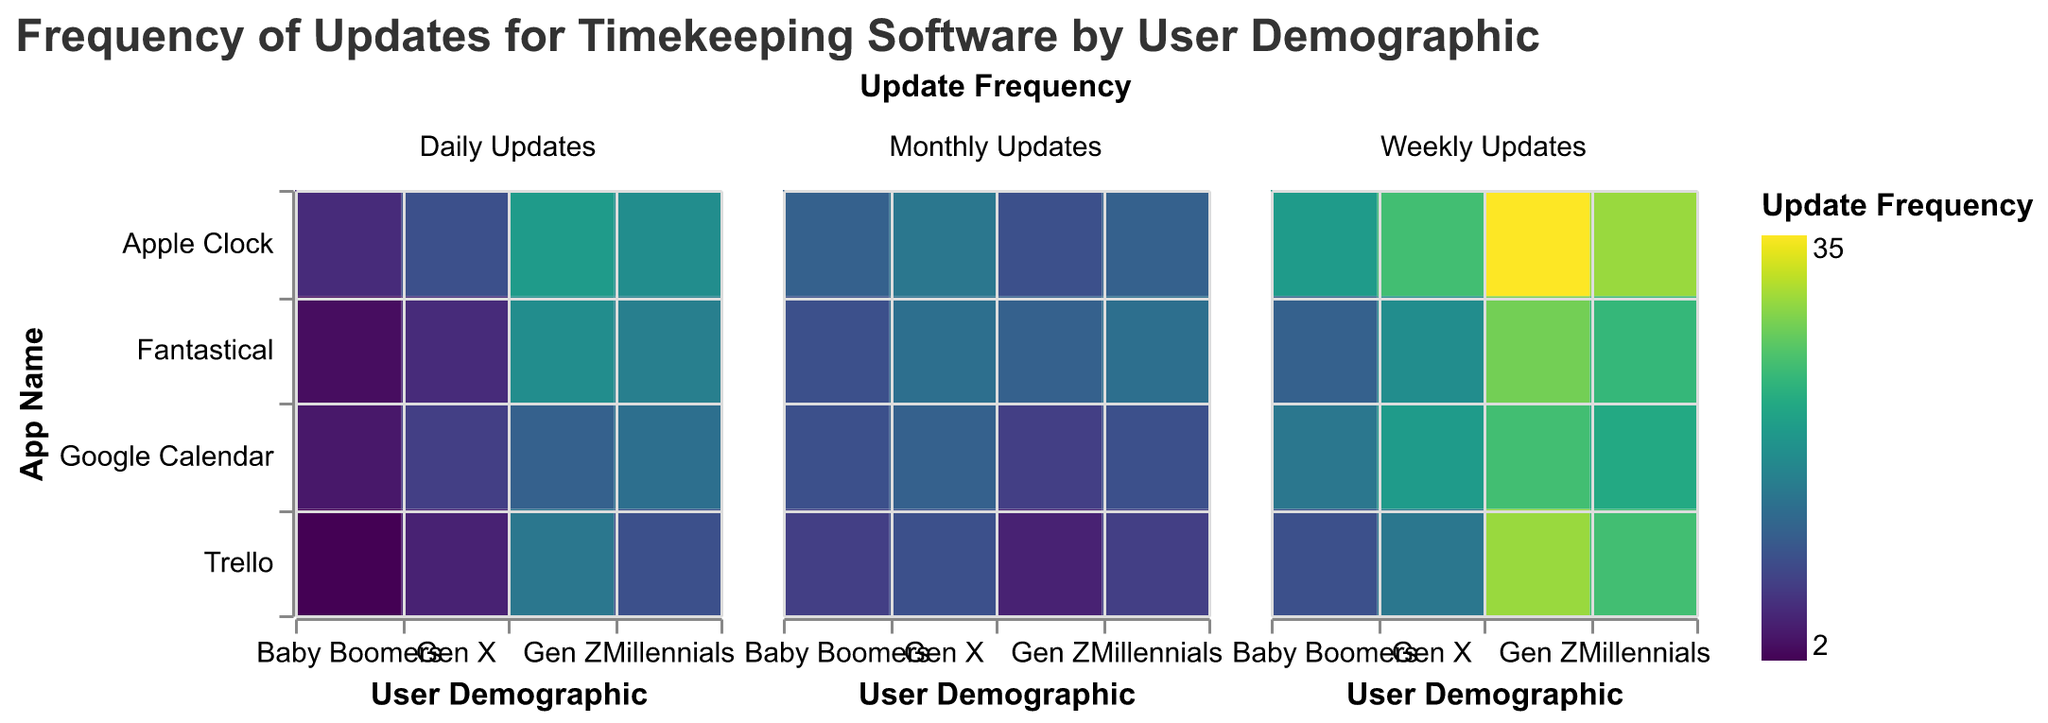How many user demographics are shown in the figure? The data display various timekeeping software platforms grouped by user demographics in the heatmap. We can count the number of distinct user demographic categories on the x-axis. From the heatmap, these are Gen Z, Millennials, Gen X, and Baby Boomers, which makes a total of four.
Answer: Four Which app has the highest number of daily updates for Gen Z? We need to look at the section of the heatmap for the Gen Z demographic and find out which app has the highest value for daily updates. According to the visual data, the Apple Clock app has the highest daily updates for Gen Z with 20.
Answer: Apple Clock Comparing Baby Boomers and Gen X, which user demographic updates 'Trello' more frequently on a daily basis? We compare the daily updates for Trello by Baby Boomers and Gen X from the heatmap. Baby Boomers show a value of 2 daily updates, and Gen X shows a value of 5 daily updates. Therefore, Gen X updates Trello more frequently daily.
Answer: Gen X What is the average weekly update frequency for Google Calendar across all user demographics? To find the average, we sum the weekly updates for Google Calendar across all demographics and then divide by the number of demographics. The values are 25 (Gen Z) + 22 (Millennials) + 20 (Gen X) + 15 (Baby Boomers) = 82. Since there are 4 demographics, the average is 82 / 4 = 20.5.
Answer: 20.5 Which app has the least monthly updates for Millennials? Referring to the section for Millennials in the heatmap and looking at the monthly updates column, Trello has 8, Google Calendar has 10, Apple Clock has 12, and Fantastical has 14 monthly updates. The least monthly updates for Millennials is for Trello with 8.
Answer: Trello Between 'Google Calendar' and 'Fantastical', which app do Baby Boomers update more frequently on a weekly basis? For Baby Boomers, Google Calendar has 15 weekly updates, while Fantastical has 12. So, Baby Boomers update Google Calendar more frequently on a weekly basis.
Answer: Google Calendar Considering only the 'Apple Clock' app, what is the difference in daily update frequency between Gen Z and Baby Boomers? From the heatmap, the daily update frequency for the Apple Clock app is 20 for Gen Z and 6 for Baby Boomers. The difference is 20 - 6 = 14.
Answer: 14 How does the update frequency for 'Fantastical' compare across the Gen Z and Gen X demographics? Focusing on Fantastical for both Gen Z and Gen X, the heatmap shows daily, weekly, and monthly updates for each. For Gen Z: 18 (daily), 28 (weekly), 12 (monthly). For Gen X: 6 (daily), 18 (weekly), 14 (monthly). Gen Z regularly updates Fantastical more frequently for all categories (daily, weekly).
Answer: Gen Z has more frequent updates What is the total number of monthly updates for 'Trello' across all demographics? Adding the monthly updates for Trello across all demographics: 5 (Gen Z) + 8 (Millennials) + 10 (Gen X) + 8 (Baby Boomers) = 31.
Answer: 31 